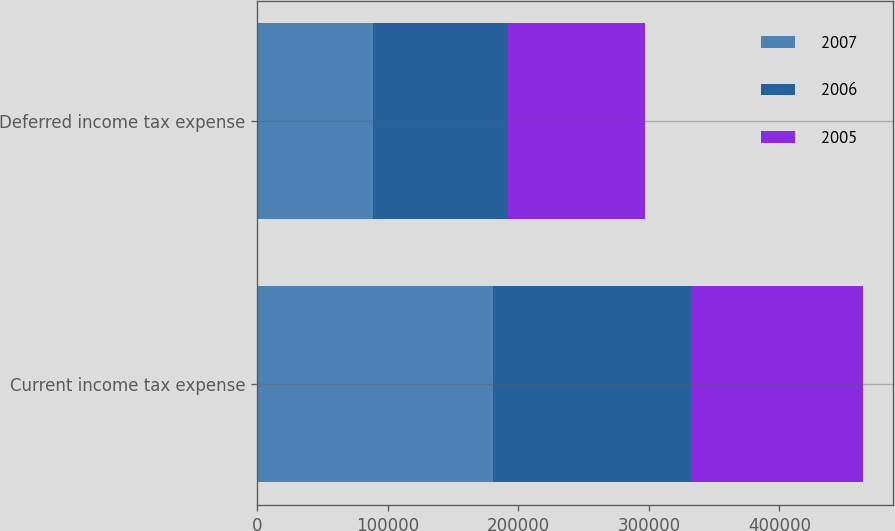Convert chart. <chart><loc_0><loc_0><loc_500><loc_500><stacked_bar_chart><ecel><fcel>Current income tax expense<fcel>Deferred income tax expense<nl><fcel>2007<fcel>180322<fcel>88948<nl><fcel>2006<fcel>151841<fcel>103098<nl><fcel>2005<fcel>131491<fcel>104640<nl></chart> 